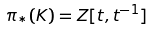Convert formula to latex. <formula><loc_0><loc_0><loc_500><loc_500>\pi _ { * } ( K ) = Z [ t , t ^ { - 1 } ]</formula> 